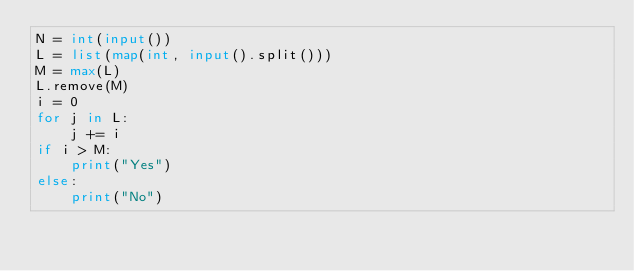Convert code to text. <code><loc_0><loc_0><loc_500><loc_500><_Python_>N = int(input())
L = list(map(int, input().split()))
M = max(L)
L.remove(M)
i = 0
for j in L:
    j += i
if i > M:
    print("Yes")
else:
    print("No")
</code> 